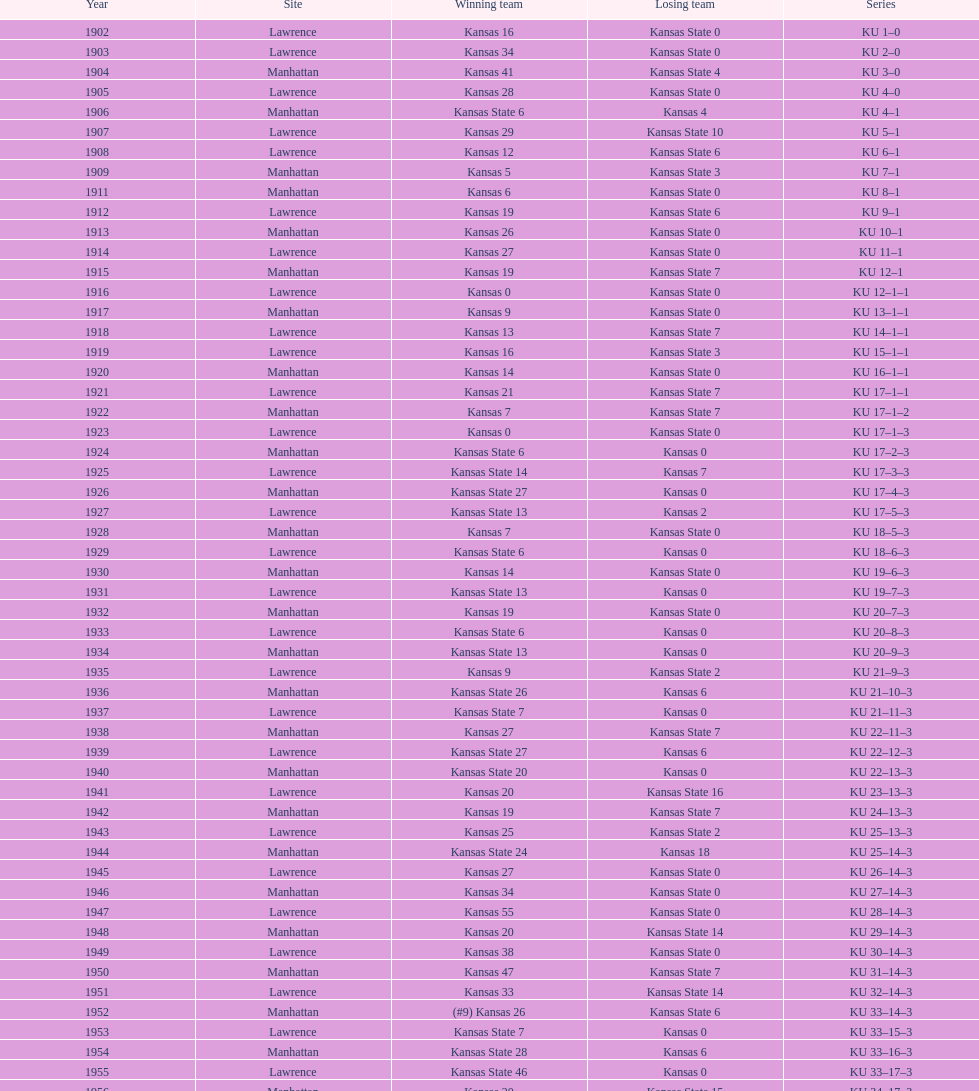Which team was more successful in terms of wins during the 1950s - kansas or kansas state? Kansas. 